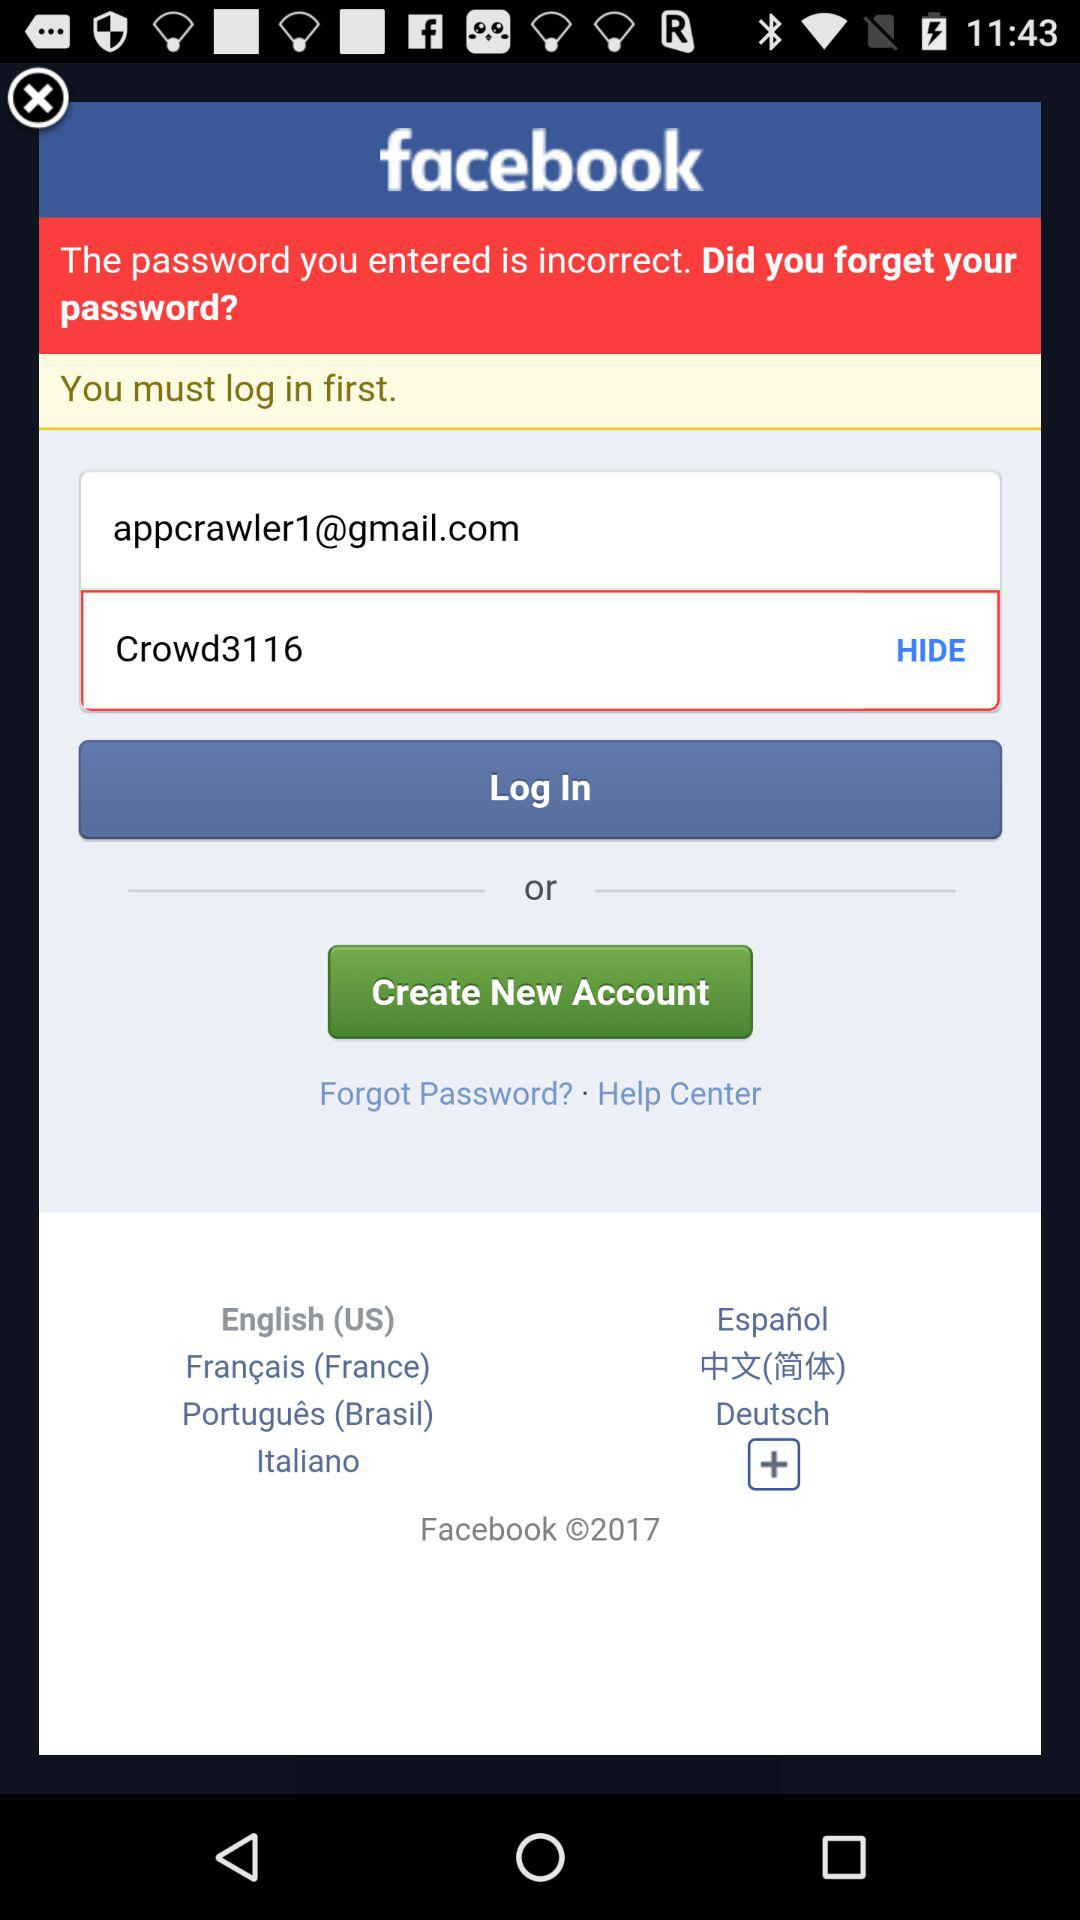How many characters are required to create a password?
When the provided information is insufficient, respond with <no answer>. <no answer> 